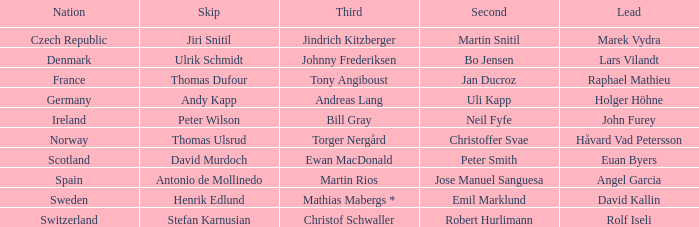When did France come in second? Jan Ducroz. 